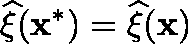Convert formula to latex. <formula><loc_0><loc_0><loc_500><loc_500>\widehat { \xi } ( x ^ { * } ) = \widehat { \xi } ( x )</formula> 